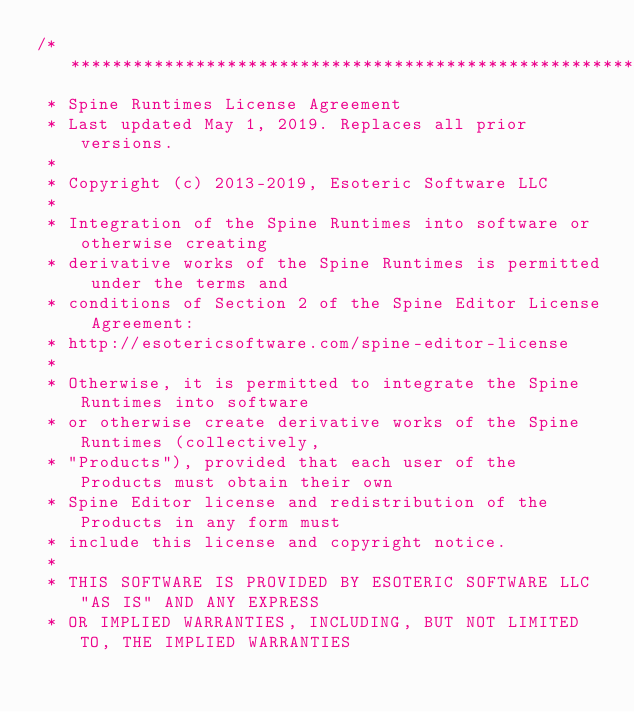<code> <loc_0><loc_0><loc_500><loc_500><_C++_>/******************************************************************************
 * Spine Runtimes License Agreement
 * Last updated May 1, 2019. Replaces all prior versions.
 *
 * Copyright (c) 2013-2019, Esoteric Software LLC
 *
 * Integration of the Spine Runtimes into software or otherwise creating
 * derivative works of the Spine Runtimes is permitted under the terms and
 * conditions of Section 2 of the Spine Editor License Agreement:
 * http://esotericsoftware.com/spine-editor-license
 *
 * Otherwise, it is permitted to integrate the Spine Runtimes into software
 * or otherwise create derivative works of the Spine Runtimes (collectively,
 * "Products"), provided that each user of the Products must obtain their own
 * Spine Editor license and redistribution of the Products in any form must
 * include this license and copyright notice.
 *
 * THIS SOFTWARE IS PROVIDED BY ESOTERIC SOFTWARE LLC "AS IS" AND ANY EXPRESS
 * OR IMPLIED WARRANTIES, INCLUDING, BUT NOT LIMITED TO, THE IMPLIED WARRANTIES</code> 